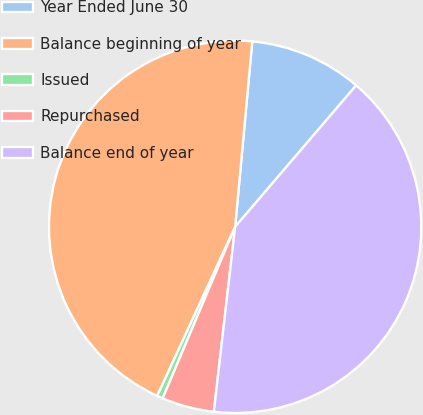Convert chart. <chart><loc_0><loc_0><loc_500><loc_500><pie_chart><fcel>Year Ended June 30<fcel>Balance beginning of year<fcel>Issued<fcel>Repurchased<fcel>Balance end of year<nl><fcel>9.8%<fcel>44.59%<fcel>0.51%<fcel>4.54%<fcel>40.56%<nl></chart> 